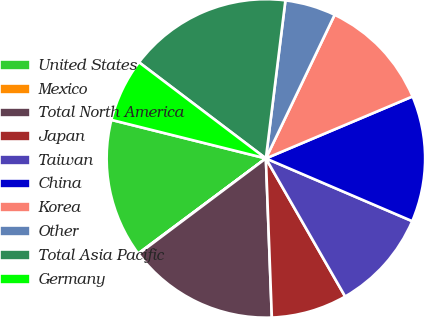Convert chart to OTSL. <chart><loc_0><loc_0><loc_500><loc_500><pie_chart><fcel>United States<fcel>Mexico<fcel>Total North America<fcel>Japan<fcel>Taiwan<fcel>China<fcel>Korea<fcel>Other<fcel>Total Asia Pacific<fcel>Germany<nl><fcel>14.08%<fcel>0.05%<fcel>15.36%<fcel>7.7%<fcel>10.26%<fcel>12.81%<fcel>11.53%<fcel>5.15%<fcel>16.64%<fcel>6.43%<nl></chart> 